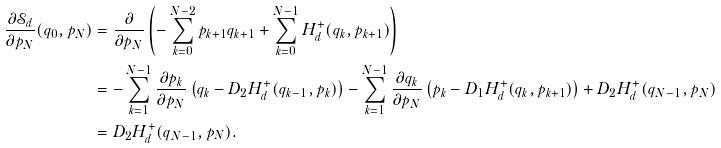Convert formula to latex. <formula><loc_0><loc_0><loc_500><loc_500>\frac { \partial \mathcal { S } _ { d } } { \partial p _ { N } } ( q _ { 0 } , p _ { N } ) & = \frac { \partial } { \partial p _ { N } } \left ( - \sum _ { k = 0 } ^ { N - 2 } p _ { k + 1 } q _ { k + 1 } + \sum _ { k = 0 } ^ { N - 1 } H _ { d } ^ { + } ( q _ { k } , p _ { k + 1 } ) \right ) \\ & = - \sum _ { k = 1 } ^ { N - 1 } \frac { \partial p _ { k } } { \partial p _ { N } } \left ( q _ { k } - D _ { 2 } H _ { d } ^ { + } ( q _ { k - 1 } , p _ { k } ) \right ) - \sum _ { k = 1 } ^ { N - 1 } \frac { \partial q _ { k } } { \partial p _ { N } } \left ( p _ { k } - D _ { 1 } H _ { d } ^ { + } ( q _ { k } , p _ { k + 1 } ) \right ) + D _ { 2 } H _ { d } ^ { + } ( q _ { N - 1 } , p _ { N } ) \\ & = D _ { 2 } H _ { d } ^ { + } ( q _ { N - 1 } , p _ { N } ) .</formula> 